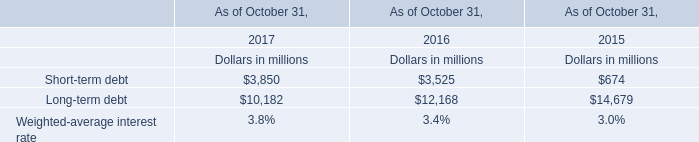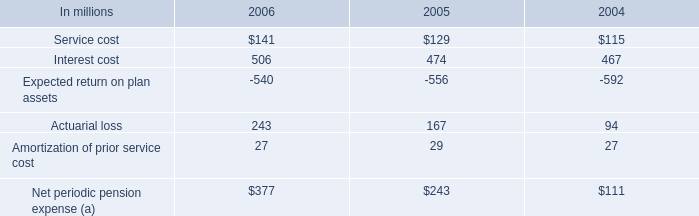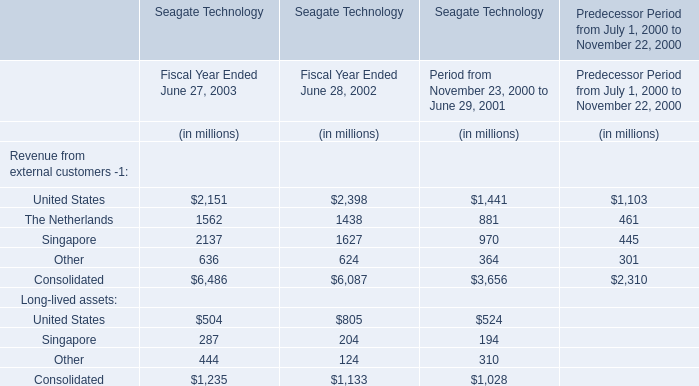If The Netherlands develops with the same increasing rate in 2003, what will it reach in 2004? (in million) 
Computations: (1562 * (1 + ((1562 - 1438) / 1438)))
Answer: 1696.69263. 